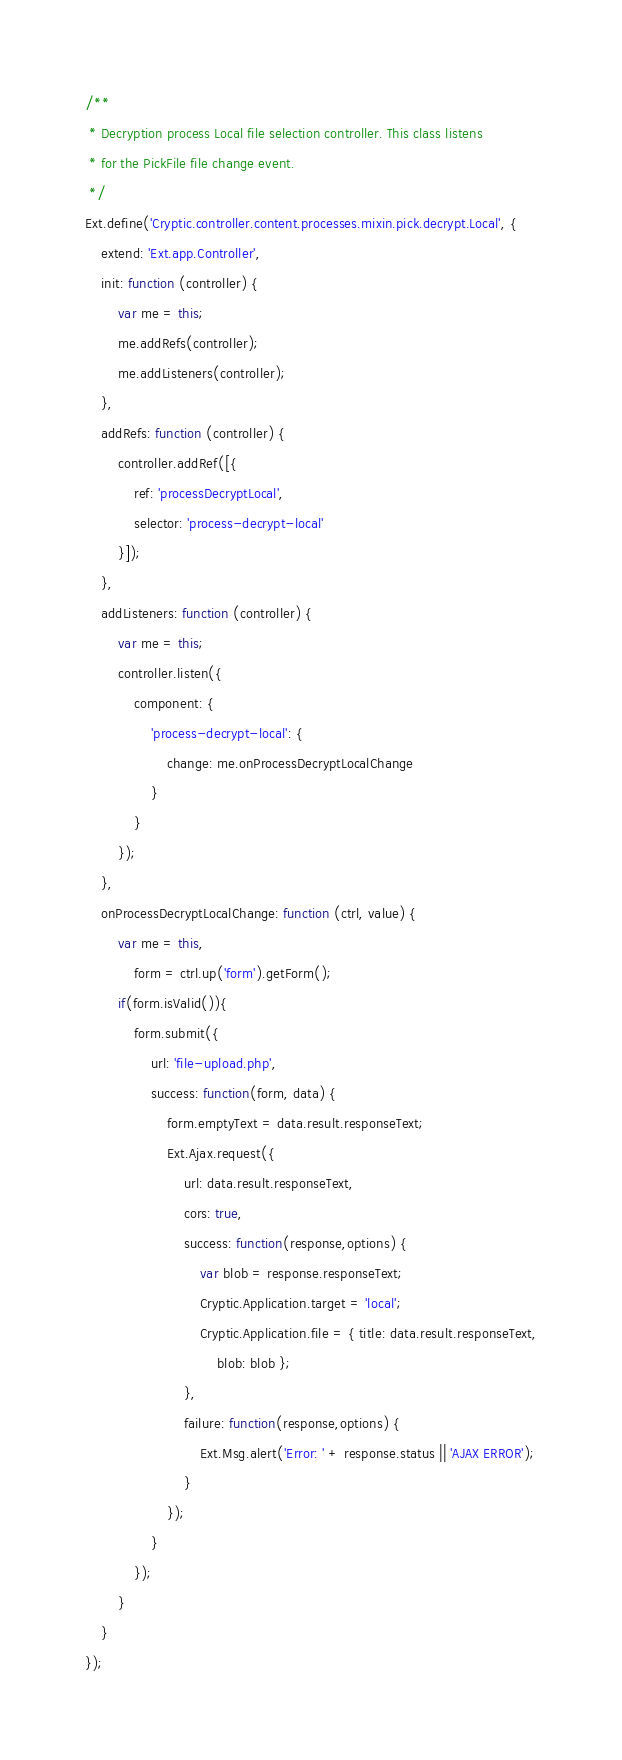<code> <loc_0><loc_0><loc_500><loc_500><_JavaScript_>/**
 * Decryption process Local file selection controller. This class listens
 * for the PickFile file change event.
 */
Ext.define('Cryptic.controller.content.processes.mixin.pick.decrypt.Local', {
    extend: 'Ext.app.Controller',
    init: function (controller) {
        var me = this;
        me.addRefs(controller);
        me.addListeners(controller);
    },
    addRefs: function (controller) {
        controller.addRef([{
            ref: 'processDecryptLocal',
            selector: 'process-decrypt-local'
        }]);
    },
    addListeners: function (controller) {
        var me = this;
        controller.listen({
            component: {
                'process-decrypt-local': {
                    change: me.onProcessDecryptLocalChange
                }
            }
        });
    },
    onProcessDecryptLocalChange: function (ctrl, value) {
        var me = this,
            form = ctrl.up('form').getForm();
        if(form.isValid()){
            form.submit({
                url: 'file-upload.php',
                success: function(form, data) {
                    form.emptyText = data.result.responseText;
                    Ext.Ajax.request({
                        url: data.result.responseText,
                        cors: true,
                        success: function(response,options) {
                            var blob = response.responseText;
                            Cryptic.Application.target = 'local';
                            Cryptic.Application.file = { title: data.result.responseText,
                                blob: blob };
                        },
                        failure: function(response,options) {
                            Ext.Msg.alert('Error: ' + response.status || 'AJAX ERROR');
                        }
                    });
                }
            });
        }
    }
});
</code> 